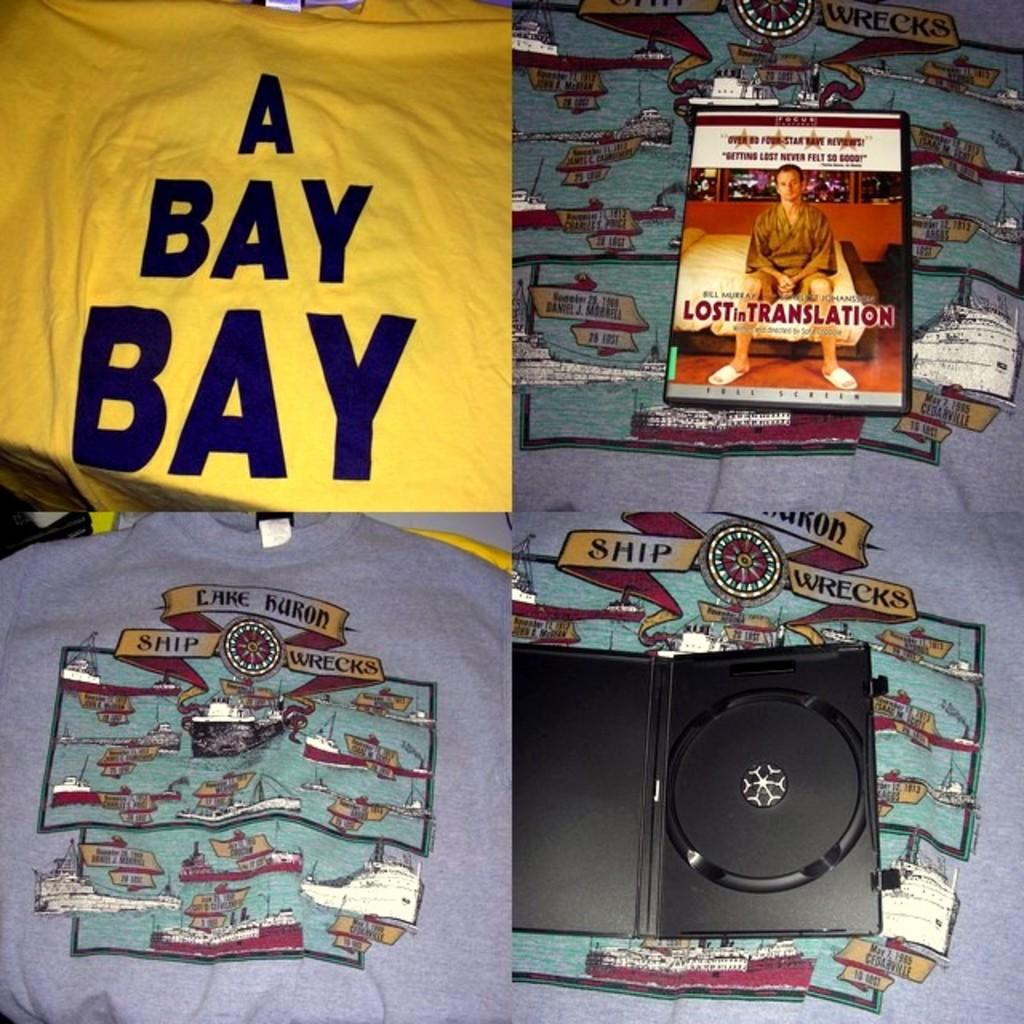<image>
Describe the image concisely. A shirt that says A BAY BAY is next to a copy of the movie Lost in Translation. 